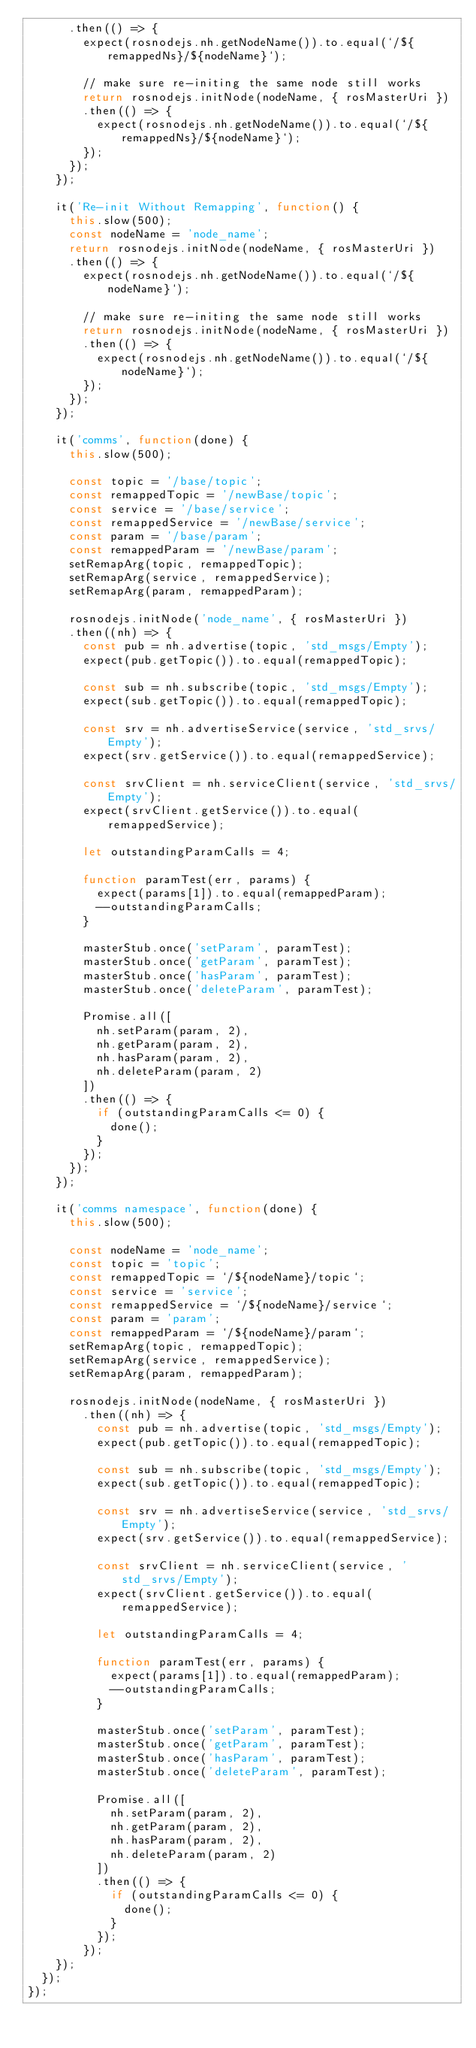<code> <loc_0><loc_0><loc_500><loc_500><_JavaScript_>      .then(() => {
        expect(rosnodejs.nh.getNodeName()).to.equal(`/${remappedNs}/${nodeName}`);

        // make sure re-initing the same node still works
        return rosnodejs.initNode(nodeName, { rosMasterUri })
        .then(() => {
          expect(rosnodejs.nh.getNodeName()).to.equal(`/${remappedNs}/${nodeName}`);
        });
      });
    });

    it('Re-init Without Remapping', function() {
      this.slow(500);
      const nodeName = 'node_name';
      return rosnodejs.initNode(nodeName, { rosMasterUri })
      .then(() => {
        expect(rosnodejs.nh.getNodeName()).to.equal(`/${nodeName}`);

        // make sure re-initing the same node still works
        return rosnodejs.initNode(nodeName, { rosMasterUri })
        .then(() => {
          expect(rosnodejs.nh.getNodeName()).to.equal(`/${nodeName}`);
        });
      });
    });

    it('comms', function(done) {
      this.slow(500);

      const topic = '/base/topic';
      const remappedTopic = '/newBase/topic';
      const service = '/base/service';
      const remappedService = '/newBase/service';
      const param = '/base/param';
      const remappedParam = '/newBase/param';
      setRemapArg(topic, remappedTopic);
      setRemapArg(service, remappedService);
      setRemapArg(param, remappedParam);

      rosnodejs.initNode('node_name', { rosMasterUri })
      .then((nh) => {
        const pub = nh.advertise(topic, 'std_msgs/Empty');
        expect(pub.getTopic()).to.equal(remappedTopic);

        const sub = nh.subscribe(topic, 'std_msgs/Empty');
        expect(sub.getTopic()).to.equal(remappedTopic);

        const srv = nh.advertiseService(service, 'std_srvs/Empty');
        expect(srv.getService()).to.equal(remappedService);

        const srvClient = nh.serviceClient(service, 'std_srvs/Empty');
        expect(srvClient.getService()).to.equal(remappedService);

        let outstandingParamCalls = 4;

        function paramTest(err, params) {
          expect(params[1]).to.equal(remappedParam);
          --outstandingParamCalls;
        }

        masterStub.once('setParam', paramTest);
        masterStub.once('getParam', paramTest);
        masterStub.once('hasParam', paramTest);
        masterStub.once('deleteParam', paramTest);

        Promise.all([
          nh.setParam(param, 2),
          nh.getParam(param, 2),
          nh.hasParam(param, 2),
          nh.deleteParam(param, 2)
        ])
        .then(() => {
          if (outstandingParamCalls <= 0) {
            done();
          }
        });
      });
    });

    it('comms namespace', function(done) {
      this.slow(500);

      const nodeName = 'node_name';
      const topic = 'topic';
      const remappedTopic = `/${nodeName}/topic`;
      const service = 'service';
      const remappedService = `/${nodeName}/service`;
      const param = 'param';
      const remappedParam = `/${nodeName}/param`;
      setRemapArg(topic, remappedTopic);
      setRemapArg(service, remappedService);
      setRemapArg(param, remappedParam);

      rosnodejs.initNode(nodeName, { rosMasterUri })
        .then((nh) => {
          const pub = nh.advertise(topic, 'std_msgs/Empty');
          expect(pub.getTopic()).to.equal(remappedTopic);

          const sub = nh.subscribe(topic, 'std_msgs/Empty');
          expect(sub.getTopic()).to.equal(remappedTopic);

          const srv = nh.advertiseService(service, 'std_srvs/Empty');
          expect(srv.getService()).to.equal(remappedService);

          const srvClient = nh.serviceClient(service, 'std_srvs/Empty');
          expect(srvClient.getService()).to.equal(remappedService);

          let outstandingParamCalls = 4;

          function paramTest(err, params) {
            expect(params[1]).to.equal(remappedParam);
            --outstandingParamCalls;
          }

          masterStub.once('setParam', paramTest);
          masterStub.once('getParam', paramTest);
          masterStub.once('hasParam', paramTest);
          masterStub.once('deleteParam', paramTest);

          Promise.all([
            nh.setParam(param, 2),
            nh.getParam(param, 2),
            nh.hasParam(param, 2),
            nh.deleteParam(param, 2)
          ])
          .then(() => {
            if (outstandingParamCalls <= 0) {
              done();
            }
          });
        });
    });
  });
});
</code> 